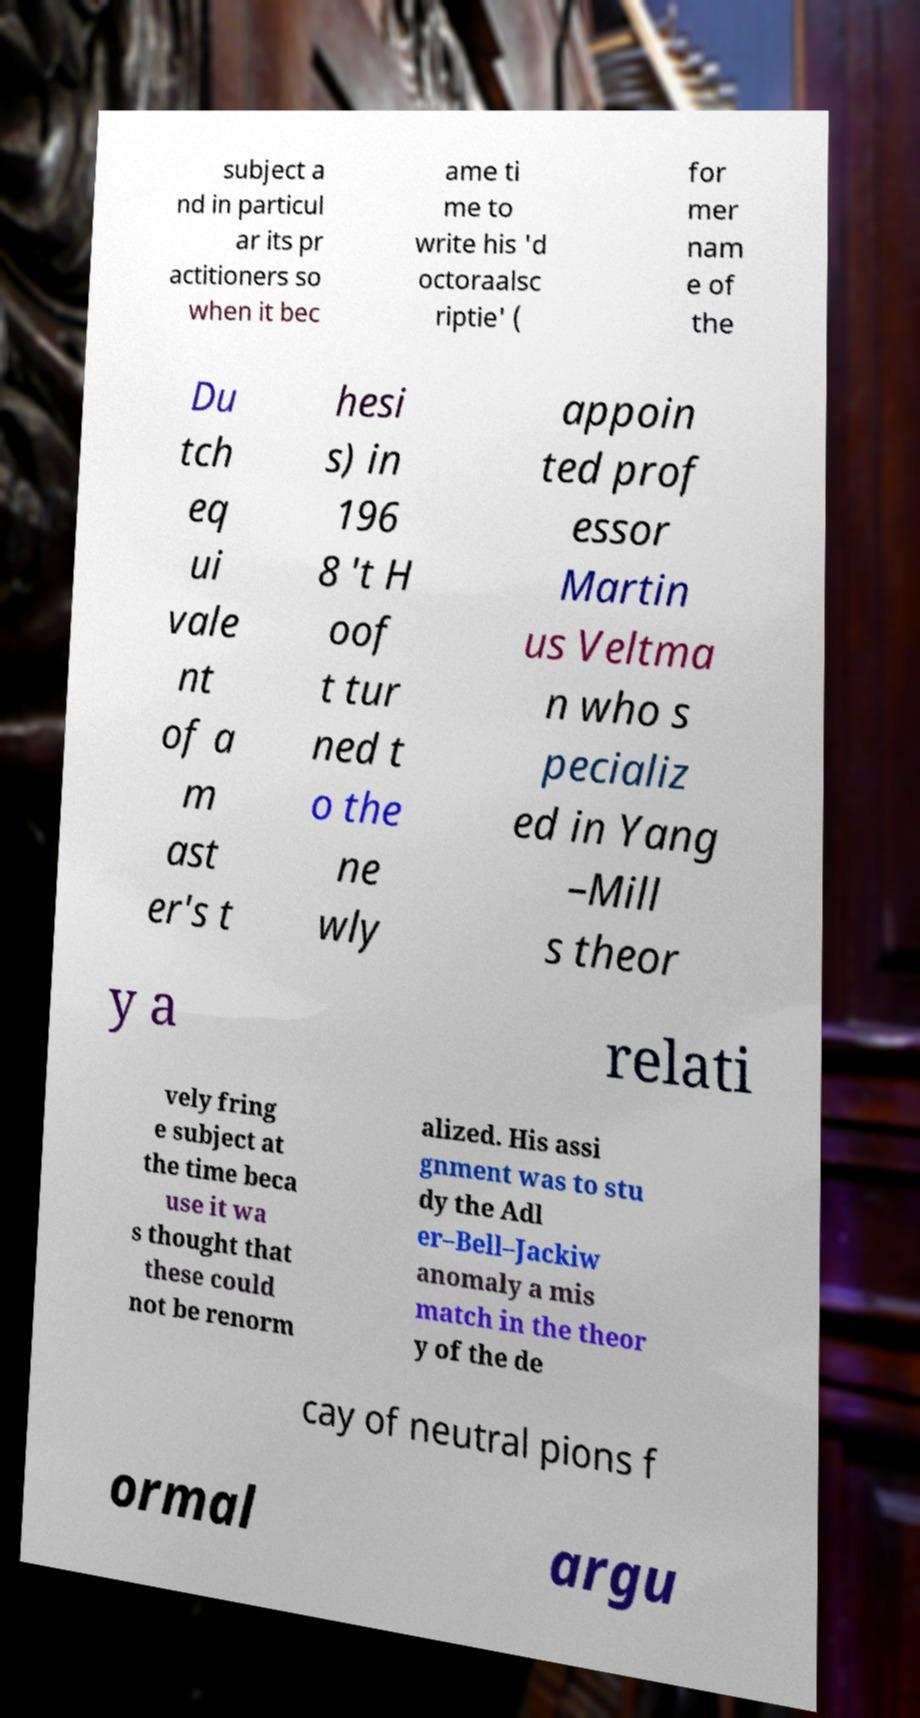Please identify and transcribe the text found in this image. subject a nd in particul ar its pr actitioners so when it bec ame ti me to write his 'd octoraalsc riptie' ( for mer nam e of the Du tch eq ui vale nt of a m ast er's t hesi s) in 196 8 't H oof t tur ned t o the ne wly appoin ted prof essor Martin us Veltma n who s pecializ ed in Yang –Mill s theor y a relati vely fring e subject at the time beca use it wa s thought that these could not be renorm alized. His assi gnment was to stu dy the Adl er–Bell–Jackiw anomaly a mis match in the theor y of the de cay of neutral pions f ormal argu 